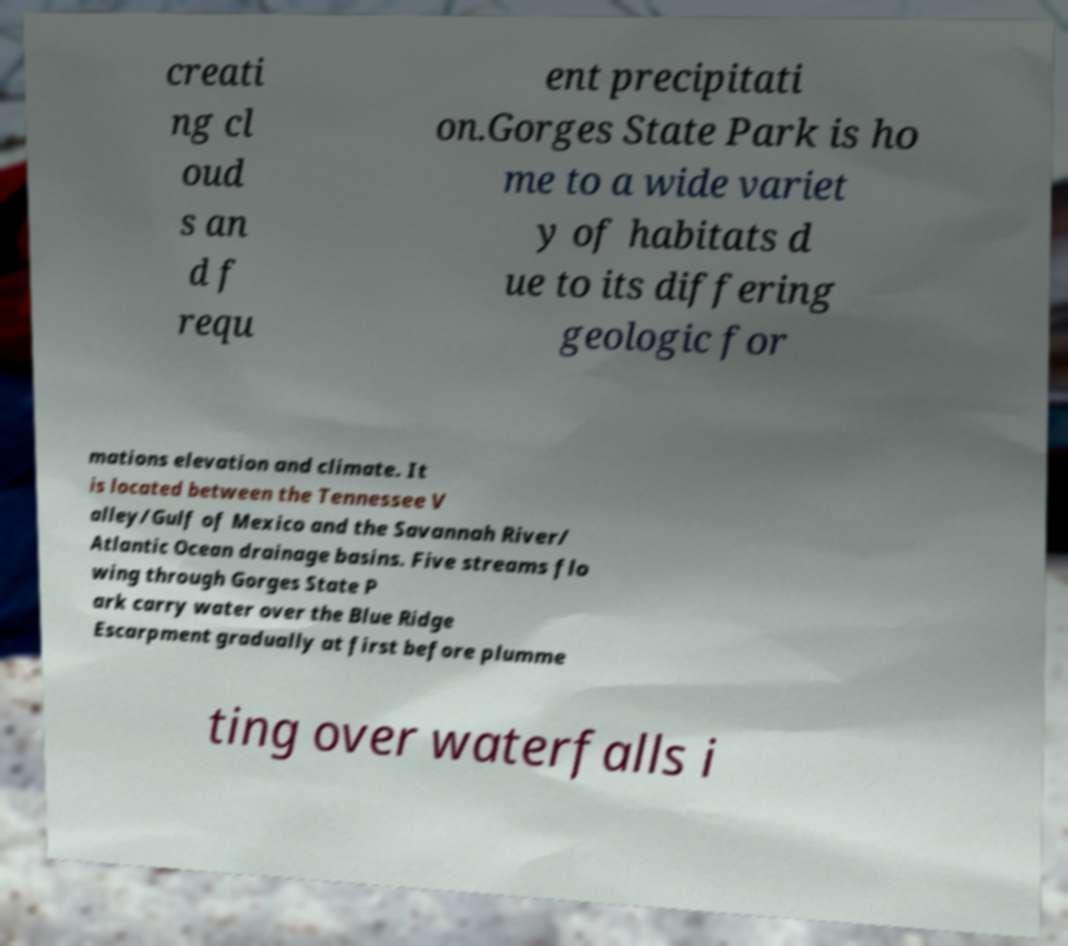I need the written content from this picture converted into text. Can you do that? creati ng cl oud s an d f requ ent precipitati on.Gorges State Park is ho me to a wide variet y of habitats d ue to its differing geologic for mations elevation and climate. It is located between the Tennessee V alley/Gulf of Mexico and the Savannah River/ Atlantic Ocean drainage basins. Five streams flo wing through Gorges State P ark carry water over the Blue Ridge Escarpment gradually at first before plumme ting over waterfalls i 